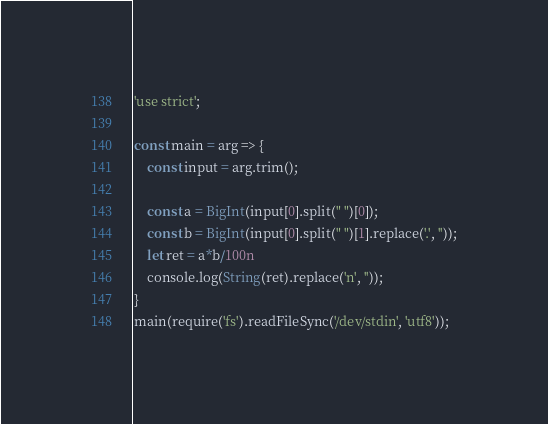Convert code to text. <code><loc_0><loc_0><loc_500><loc_500><_JavaScript_>'use strict';

const main = arg => {
    const input = arg.trim();
 
    const a = BigInt(input[0].split(" ")[0]);
    const b = BigInt(input[0].split(" ")[1].replace('.', ''));
    let ret = a*b/100n
    console.log(String(ret).replace('n', ''));
}
main(require('fs').readFileSync('/dev/stdin', 'utf8'));  </code> 